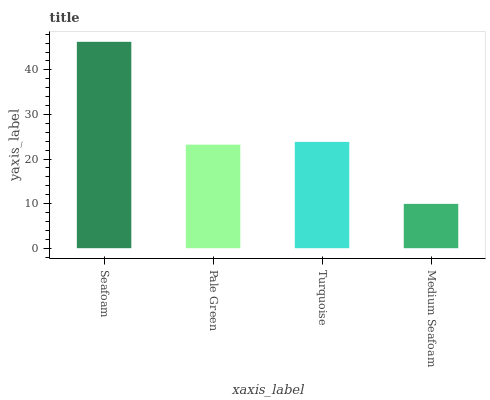Is Medium Seafoam the minimum?
Answer yes or no. Yes. Is Seafoam the maximum?
Answer yes or no. Yes. Is Pale Green the minimum?
Answer yes or no. No. Is Pale Green the maximum?
Answer yes or no. No. Is Seafoam greater than Pale Green?
Answer yes or no. Yes. Is Pale Green less than Seafoam?
Answer yes or no. Yes. Is Pale Green greater than Seafoam?
Answer yes or no. No. Is Seafoam less than Pale Green?
Answer yes or no. No. Is Turquoise the high median?
Answer yes or no. Yes. Is Pale Green the low median?
Answer yes or no. Yes. Is Pale Green the high median?
Answer yes or no. No. Is Turquoise the low median?
Answer yes or no. No. 